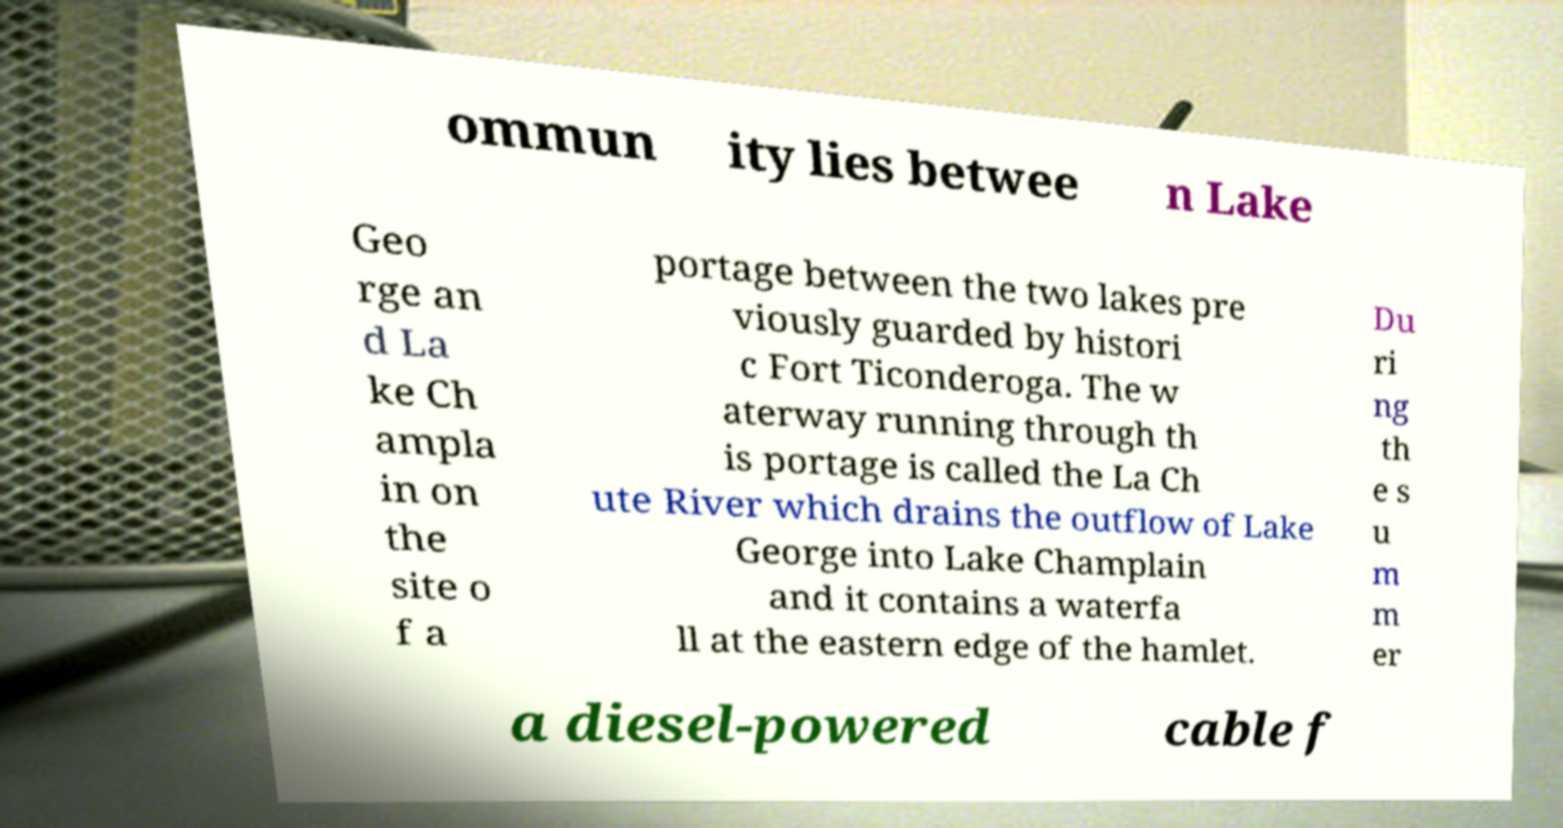Please identify and transcribe the text found in this image. ommun ity lies betwee n Lake Geo rge an d La ke Ch ampla in on the site o f a portage between the two lakes pre viously guarded by histori c Fort Ticonderoga. The w aterway running through th is portage is called the La Ch ute River which drains the outflow of Lake George into Lake Champlain and it contains a waterfa ll at the eastern edge of the hamlet. Du ri ng th e s u m m er a diesel-powered cable f 